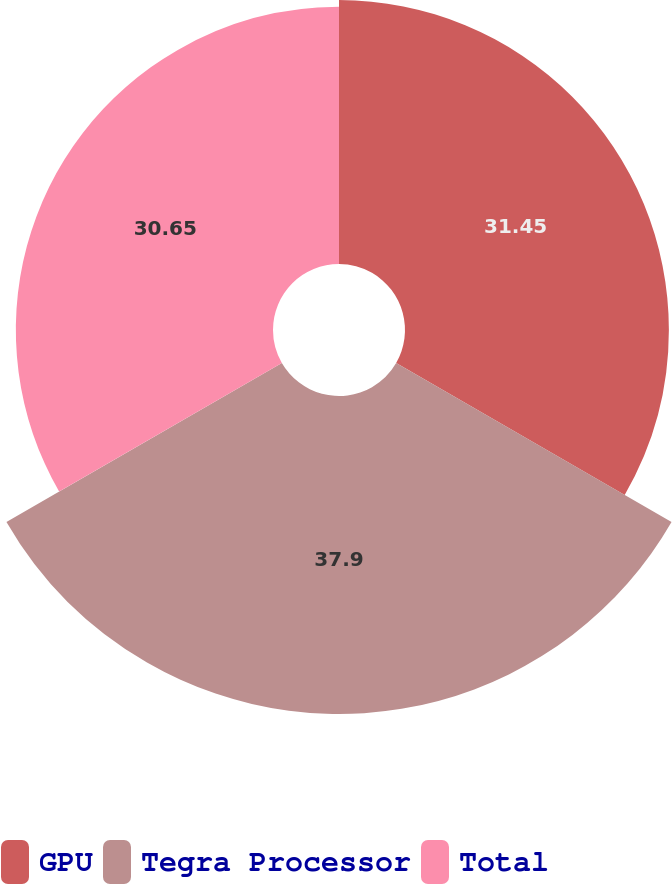Convert chart. <chart><loc_0><loc_0><loc_500><loc_500><pie_chart><fcel>GPU<fcel>Tegra Processor<fcel>Total<nl><fcel>31.45%<fcel>37.9%<fcel>30.65%<nl></chart> 